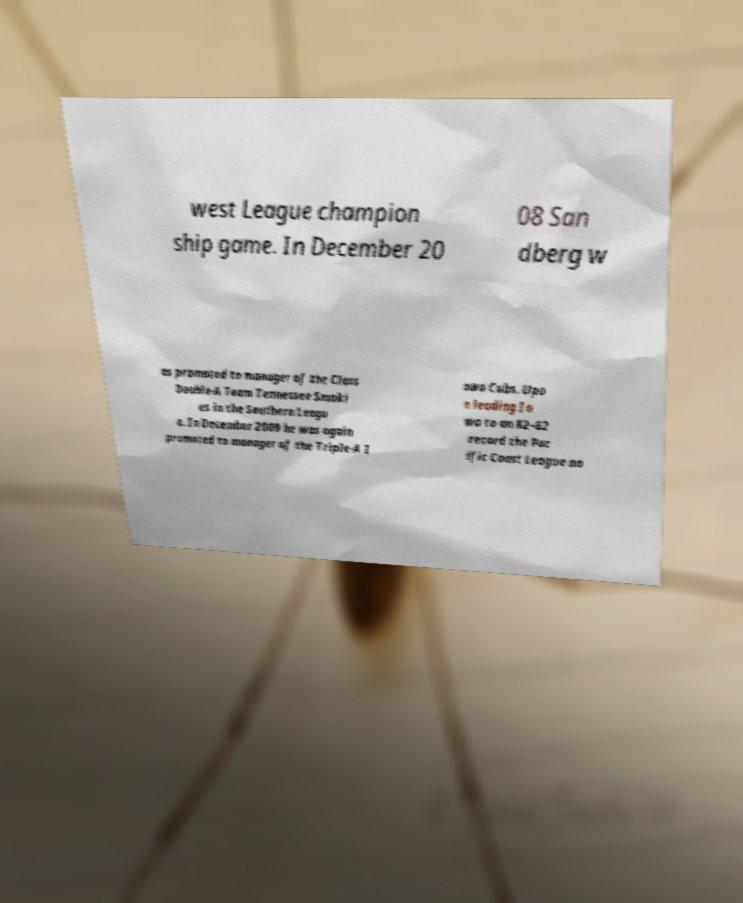There's text embedded in this image that I need extracted. Can you transcribe it verbatim? west League champion ship game. In December 20 08 San dberg w as promoted to manager of the Class Double-A Team Tennessee Smoki es in the Southern Leagu e. In December 2009 he was again promoted to manager of the Triple-A I owa Cubs. Upo n leading Io wa to an 82–62 record the Pac ific Coast League na 